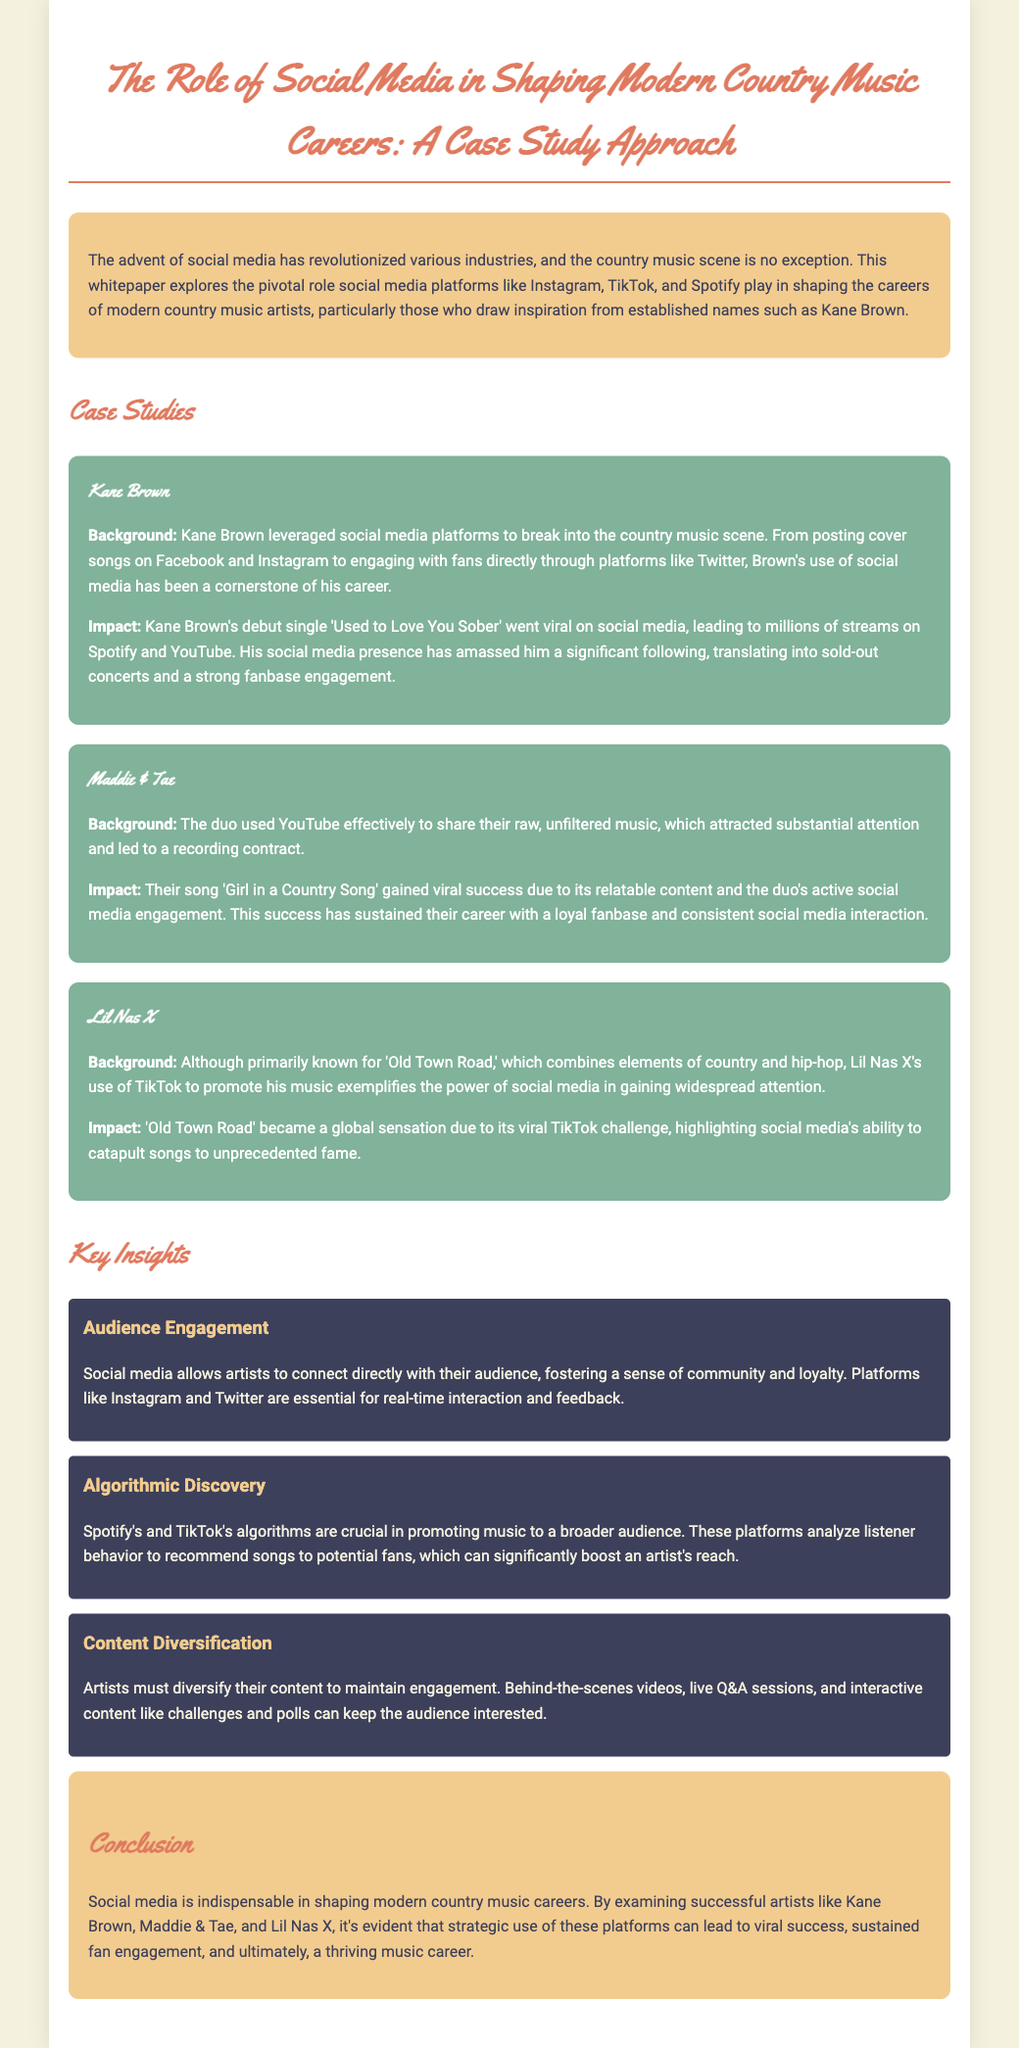What is the title of the whitepaper? The title is listed at the top of the document under the main heading.
Answer: The Role of Social Media in Shaping Modern Country Music Careers: A Case Study Approach Who is the first artist mentioned in the case studies? The first artist mentioned in the case studies section provides insight into their social media strategy.
Answer: Kane Brown What song by Kane Brown went viral? The song that became popular is highlighted within the background of his case study.
Answer: Used to Love You Sober Which social media platform is primarily associated with Maddie & Tae? The document specifies the platform they utilized effectively to share their music.
Answer: YouTube What global sensation is associated with Lil Nas X? The case study details a prominent song that gained fame.
Answer: Old Town Road How does social media facilitate audience engagement? The whitepaper discusses the direct connection artists can have with their audience through social media platforms.
Answer: Community and loyalty What are the two platforms mentioned that are important for algorithmic discovery? These platforms are noted for their role in promoting music to audiences based on listener behavior.
Answer: Spotify and TikTok What type of content diversification is suggested for artists? The document emphasizes that artists need to keep their audience interested through various types of engaging content.
Answer: Behind-the-scenes videos What is the conclusion about the role of social media in country music? The conclusion summarizes the findings regarding the impact of social media on artist careers.
Answer: Indispensable in shaping modern country music careers 